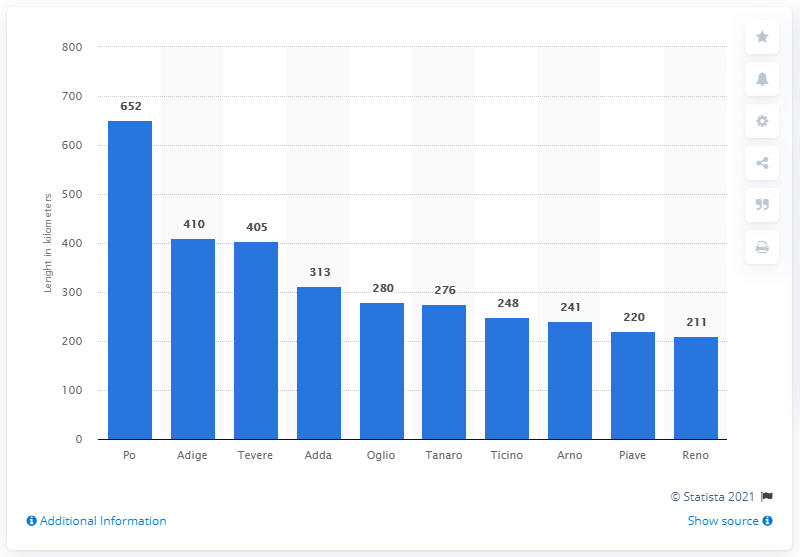Give some essential details in this illustration. The Po River is the largest river in Italy. 